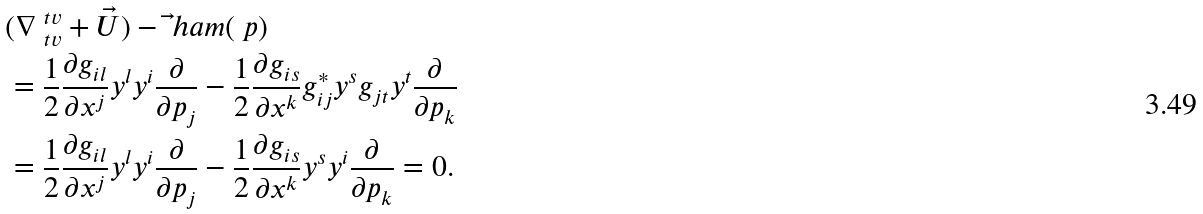Convert formula to latex. <formula><loc_0><loc_0><loc_500><loc_500>& ( \nabla ^ { \ t v } _ { \ t v } + \vec { U } ) - \vec { \ } h a m ( \ p ) \\ & = \frac { 1 } { 2 } \frac { \partial g _ { i l } } { \partial x ^ { j } } y ^ { l } y ^ { i } \frac { \partial } { \partial p _ { j } } - \frac { 1 } { 2 } \frac { \partial g _ { i s } } { \partial x ^ { k } } g ^ { * } _ { i j } y ^ { s } g _ { j t } y ^ { t } \frac { \partial } { \partial p _ { k } } \\ & = \frac { 1 } { 2 } \frac { \partial g _ { i l } } { \partial x ^ { j } } y ^ { l } y ^ { i } \frac { \partial } { \partial p _ { j } } - \frac { 1 } { 2 } \frac { \partial g _ { i s } } { \partial x ^ { k } } y ^ { s } y ^ { i } \frac { \partial } { \partial p _ { k } } = 0 .</formula> 